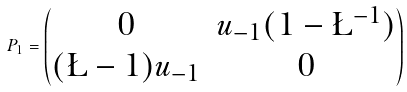Convert formula to latex. <formula><loc_0><loc_0><loc_500><loc_500>P _ { 1 } = \begin{pmatrix} 0 & u _ { - 1 } ( 1 - \L ^ { - 1 } ) \\ ( \L - 1 ) u _ { - 1 } & 0 \end{pmatrix}</formula> 